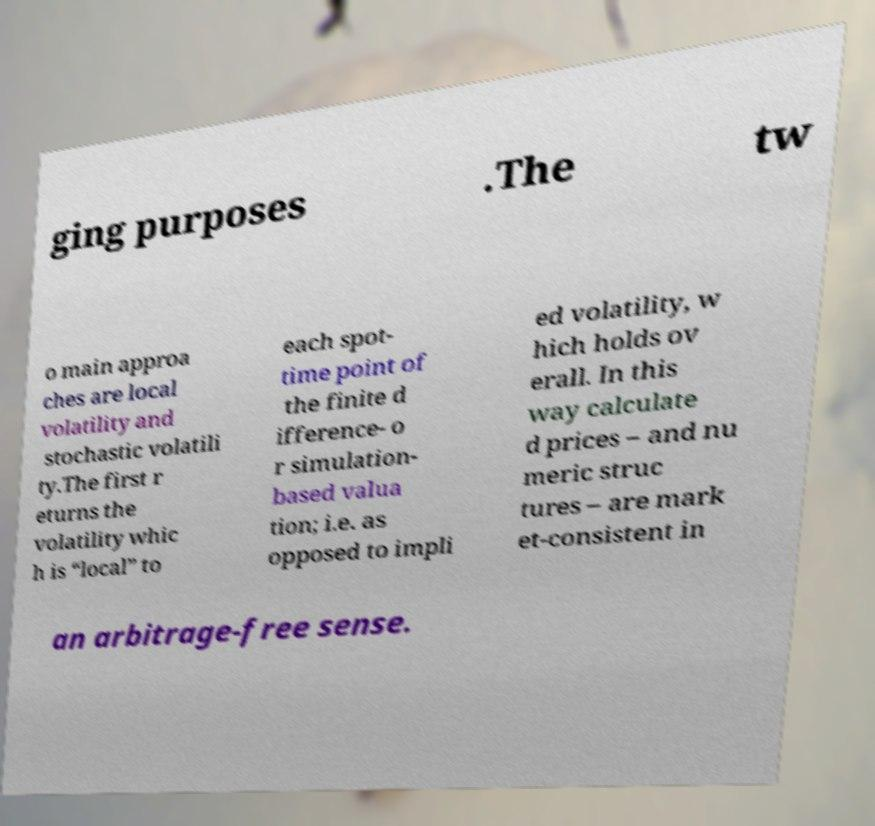Can you accurately transcribe the text from the provided image for me? ging purposes .The tw o main approa ches are local volatility and stochastic volatili ty.The first r eturns the volatility whic h is “local” to each spot- time point of the finite d ifference- o r simulation- based valua tion; i.e. as opposed to impli ed volatility, w hich holds ov erall. In this way calculate d prices – and nu meric struc tures – are mark et-consistent in an arbitrage-free sense. 